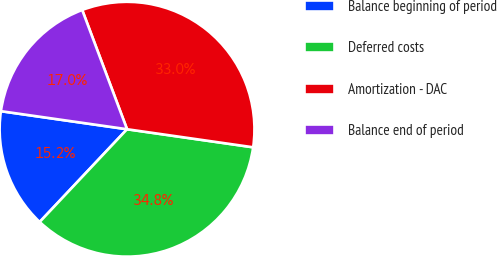Convert chart. <chart><loc_0><loc_0><loc_500><loc_500><pie_chart><fcel>Balance beginning of period<fcel>Deferred costs<fcel>Amortization - DAC<fcel>Balance end of period<nl><fcel>15.24%<fcel>34.76%<fcel>32.99%<fcel>17.01%<nl></chart> 